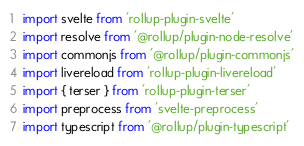Convert code to text. <code><loc_0><loc_0><loc_500><loc_500><_JavaScript_>import svelte from 'rollup-plugin-svelte'
import resolve from '@rollup/plugin-node-resolve'
import commonjs from '@rollup/plugin-commonjs'
import livereload from 'rollup-plugin-livereload'
import { terser } from 'rollup-plugin-terser'
import preprocess from 'svelte-preprocess'
import typescript from '@rollup/plugin-typescript'
</code> 